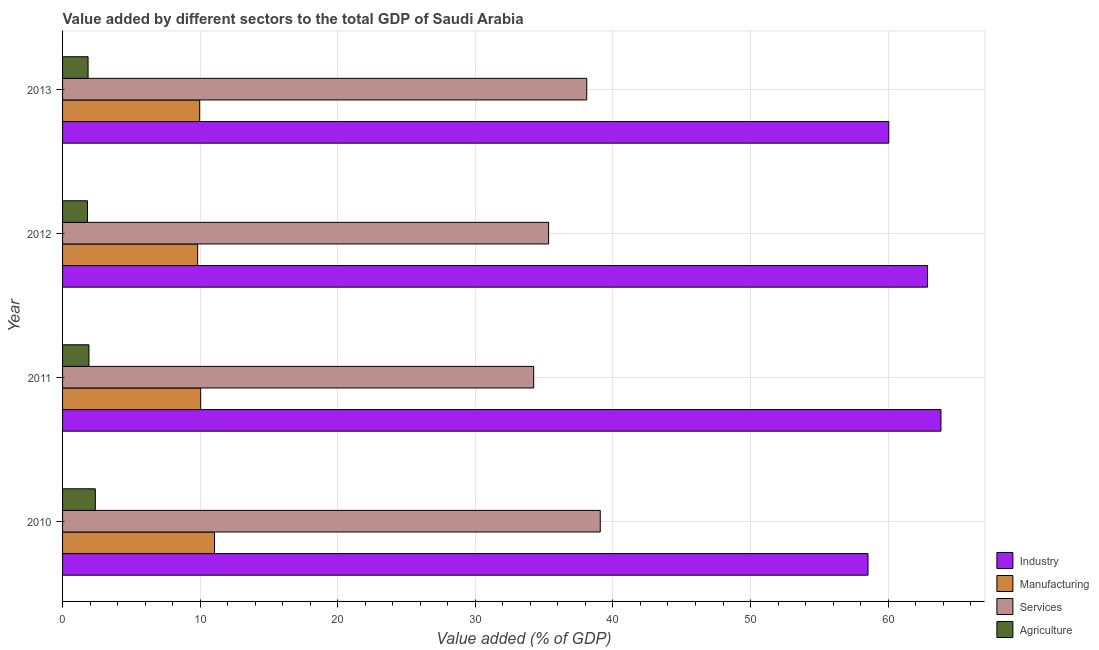How many different coloured bars are there?
Your response must be concise. 4. How many groups of bars are there?
Your response must be concise. 4. How many bars are there on the 3rd tick from the top?
Your response must be concise. 4. How many bars are there on the 2nd tick from the bottom?
Give a very brief answer. 4. What is the label of the 2nd group of bars from the top?
Your answer should be compact. 2012. What is the value added by agricultural sector in 2013?
Your response must be concise. 1.85. Across all years, what is the maximum value added by services sector?
Give a very brief answer. 39.08. Across all years, what is the minimum value added by services sector?
Offer a terse response. 34.24. In which year was the value added by agricultural sector minimum?
Keep it short and to the point. 2012. What is the total value added by industrial sector in the graph?
Offer a terse response. 245.29. What is the difference between the value added by agricultural sector in 2010 and that in 2012?
Make the answer very short. 0.57. What is the difference between the value added by industrial sector in 2013 and the value added by services sector in 2012?
Make the answer very short. 24.72. What is the average value added by manufacturing sector per year?
Your response must be concise. 10.21. In the year 2012, what is the difference between the value added by services sector and value added by industrial sector?
Provide a succinct answer. -27.54. Is the value added by services sector in 2011 less than that in 2013?
Your response must be concise. Yes. What is the difference between the highest and the second highest value added by manufacturing sector?
Make the answer very short. 1.01. In how many years, is the value added by manufacturing sector greater than the average value added by manufacturing sector taken over all years?
Offer a terse response. 1. Is the sum of the value added by manufacturing sector in 2012 and 2013 greater than the maximum value added by industrial sector across all years?
Your answer should be compact. No. What does the 4th bar from the top in 2011 represents?
Make the answer very short. Industry. What does the 2nd bar from the bottom in 2011 represents?
Your answer should be compact. Manufacturing. Are all the bars in the graph horizontal?
Your answer should be compact. Yes. How many years are there in the graph?
Your response must be concise. 4. Does the graph contain grids?
Offer a very short reply. Yes. Where does the legend appear in the graph?
Your response must be concise. Bottom right. What is the title of the graph?
Ensure brevity in your answer.  Value added by different sectors to the total GDP of Saudi Arabia. Does "Mammal species" appear as one of the legend labels in the graph?
Offer a terse response. No. What is the label or title of the X-axis?
Your response must be concise. Value added (% of GDP). What is the label or title of the Y-axis?
Provide a succinct answer. Year. What is the Value added (% of GDP) of Industry in 2010?
Your answer should be very brief. 58.54. What is the Value added (% of GDP) in Manufacturing in 2010?
Provide a short and direct response. 11.04. What is the Value added (% of GDP) in Services in 2010?
Give a very brief answer. 39.08. What is the Value added (% of GDP) of Agriculture in 2010?
Give a very brief answer. 2.38. What is the Value added (% of GDP) of Industry in 2011?
Your response must be concise. 63.84. What is the Value added (% of GDP) in Manufacturing in 2011?
Make the answer very short. 10.04. What is the Value added (% of GDP) of Services in 2011?
Make the answer very short. 34.24. What is the Value added (% of GDP) of Agriculture in 2011?
Make the answer very short. 1.92. What is the Value added (% of GDP) of Industry in 2012?
Keep it short and to the point. 62.86. What is the Value added (% of GDP) in Manufacturing in 2012?
Offer a terse response. 9.82. What is the Value added (% of GDP) of Services in 2012?
Ensure brevity in your answer.  35.33. What is the Value added (% of GDP) in Agriculture in 2012?
Offer a very short reply. 1.81. What is the Value added (% of GDP) of Industry in 2013?
Offer a terse response. 60.05. What is the Value added (% of GDP) in Manufacturing in 2013?
Keep it short and to the point. 9.96. What is the Value added (% of GDP) in Services in 2013?
Ensure brevity in your answer.  38.1. What is the Value added (% of GDP) in Agriculture in 2013?
Give a very brief answer. 1.85. Across all years, what is the maximum Value added (% of GDP) in Industry?
Provide a succinct answer. 63.84. Across all years, what is the maximum Value added (% of GDP) in Manufacturing?
Keep it short and to the point. 11.04. Across all years, what is the maximum Value added (% of GDP) in Services?
Offer a terse response. 39.08. Across all years, what is the maximum Value added (% of GDP) in Agriculture?
Make the answer very short. 2.38. Across all years, what is the minimum Value added (% of GDP) in Industry?
Ensure brevity in your answer.  58.54. Across all years, what is the minimum Value added (% of GDP) of Manufacturing?
Provide a succinct answer. 9.82. Across all years, what is the minimum Value added (% of GDP) in Services?
Your response must be concise. 34.24. Across all years, what is the minimum Value added (% of GDP) of Agriculture?
Keep it short and to the point. 1.81. What is the total Value added (% of GDP) in Industry in the graph?
Offer a very short reply. 245.29. What is the total Value added (% of GDP) of Manufacturing in the graph?
Give a very brief answer. 40.86. What is the total Value added (% of GDP) of Services in the graph?
Provide a short and direct response. 146.74. What is the total Value added (% of GDP) of Agriculture in the graph?
Give a very brief answer. 7.96. What is the difference between the Value added (% of GDP) of Industry in 2010 and that in 2011?
Your answer should be compact. -5.3. What is the difference between the Value added (% of GDP) of Manufacturing in 2010 and that in 2011?
Provide a succinct answer. 1.01. What is the difference between the Value added (% of GDP) of Services in 2010 and that in 2011?
Keep it short and to the point. 4.84. What is the difference between the Value added (% of GDP) in Agriculture in 2010 and that in 2011?
Offer a very short reply. 0.46. What is the difference between the Value added (% of GDP) of Industry in 2010 and that in 2012?
Give a very brief answer. -4.32. What is the difference between the Value added (% of GDP) of Manufacturing in 2010 and that in 2012?
Provide a short and direct response. 1.23. What is the difference between the Value added (% of GDP) in Services in 2010 and that in 2012?
Provide a succinct answer. 3.75. What is the difference between the Value added (% of GDP) in Agriculture in 2010 and that in 2012?
Make the answer very short. 0.57. What is the difference between the Value added (% of GDP) of Industry in 2010 and that in 2013?
Your answer should be very brief. -1.51. What is the difference between the Value added (% of GDP) in Manufacturing in 2010 and that in 2013?
Keep it short and to the point. 1.08. What is the difference between the Value added (% of GDP) in Services in 2010 and that in 2013?
Your answer should be very brief. 0.98. What is the difference between the Value added (% of GDP) in Agriculture in 2010 and that in 2013?
Provide a succinct answer. 0.53. What is the difference between the Value added (% of GDP) of Industry in 2011 and that in 2012?
Ensure brevity in your answer.  0.98. What is the difference between the Value added (% of GDP) of Manufacturing in 2011 and that in 2012?
Your response must be concise. 0.22. What is the difference between the Value added (% of GDP) of Services in 2011 and that in 2012?
Provide a succinct answer. -1.09. What is the difference between the Value added (% of GDP) in Agriculture in 2011 and that in 2012?
Provide a short and direct response. 0.11. What is the difference between the Value added (% of GDP) of Industry in 2011 and that in 2013?
Make the answer very short. 3.79. What is the difference between the Value added (% of GDP) in Manufacturing in 2011 and that in 2013?
Give a very brief answer. 0.08. What is the difference between the Value added (% of GDP) in Services in 2011 and that in 2013?
Your answer should be very brief. -3.86. What is the difference between the Value added (% of GDP) in Agriculture in 2011 and that in 2013?
Ensure brevity in your answer.  0.06. What is the difference between the Value added (% of GDP) in Industry in 2012 and that in 2013?
Ensure brevity in your answer.  2.82. What is the difference between the Value added (% of GDP) of Manufacturing in 2012 and that in 2013?
Your response must be concise. -0.15. What is the difference between the Value added (% of GDP) of Services in 2012 and that in 2013?
Your response must be concise. -2.77. What is the difference between the Value added (% of GDP) in Agriculture in 2012 and that in 2013?
Offer a terse response. -0.04. What is the difference between the Value added (% of GDP) in Industry in 2010 and the Value added (% of GDP) in Manufacturing in 2011?
Offer a very short reply. 48.5. What is the difference between the Value added (% of GDP) in Industry in 2010 and the Value added (% of GDP) in Services in 2011?
Make the answer very short. 24.3. What is the difference between the Value added (% of GDP) in Industry in 2010 and the Value added (% of GDP) in Agriculture in 2011?
Provide a succinct answer. 56.62. What is the difference between the Value added (% of GDP) of Manufacturing in 2010 and the Value added (% of GDP) of Services in 2011?
Offer a very short reply. -23.2. What is the difference between the Value added (% of GDP) in Manufacturing in 2010 and the Value added (% of GDP) in Agriculture in 2011?
Give a very brief answer. 9.13. What is the difference between the Value added (% of GDP) in Services in 2010 and the Value added (% of GDP) in Agriculture in 2011?
Ensure brevity in your answer.  37.16. What is the difference between the Value added (% of GDP) of Industry in 2010 and the Value added (% of GDP) of Manufacturing in 2012?
Provide a succinct answer. 48.72. What is the difference between the Value added (% of GDP) in Industry in 2010 and the Value added (% of GDP) in Services in 2012?
Keep it short and to the point. 23.21. What is the difference between the Value added (% of GDP) in Industry in 2010 and the Value added (% of GDP) in Agriculture in 2012?
Keep it short and to the point. 56.73. What is the difference between the Value added (% of GDP) of Manufacturing in 2010 and the Value added (% of GDP) of Services in 2012?
Your answer should be compact. -24.28. What is the difference between the Value added (% of GDP) in Manufacturing in 2010 and the Value added (% of GDP) in Agriculture in 2012?
Your answer should be very brief. 9.23. What is the difference between the Value added (% of GDP) in Services in 2010 and the Value added (% of GDP) in Agriculture in 2012?
Your response must be concise. 37.27. What is the difference between the Value added (% of GDP) in Industry in 2010 and the Value added (% of GDP) in Manufacturing in 2013?
Your answer should be compact. 48.58. What is the difference between the Value added (% of GDP) in Industry in 2010 and the Value added (% of GDP) in Services in 2013?
Ensure brevity in your answer.  20.44. What is the difference between the Value added (% of GDP) in Industry in 2010 and the Value added (% of GDP) in Agriculture in 2013?
Keep it short and to the point. 56.69. What is the difference between the Value added (% of GDP) in Manufacturing in 2010 and the Value added (% of GDP) in Services in 2013?
Give a very brief answer. -27.05. What is the difference between the Value added (% of GDP) in Manufacturing in 2010 and the Value added (% of GDP) in Agriculture in 2013?
Provide a short and direct response. 9.19. What is the difference between the Value added (% of GDP) in Services in 2010 and the Value added (% of GDP) in Agriculture in 2013?
Ensure brevity in your answer.  37.23. What is the difference between the Value added (% of GDP) of Industry in 2011 and the Value added (% of GDP) of Manufacturing in 2012?
Provide a short and direct response. 54.02. What is the difference between the Value added (% of GDP) in Industry in 2011 and the Value added (% of GDP) in Services in 2012?
Your response must be concise. 28.51. What is the difference between the Value added (% of GDP) in Industry in 2011 and the Value added (% of GDP) in Agriculture in 2012?
Keep it short and to the point. 62.03. What is the difference between the Value added (% of GDP) in Manufacturing in 2011 and the Value added (% of GDP) in Services in 2012?
Ensure brevity in your answer.  -25.29. What is the difference between the Value added (% of GDP) in Manufacturing in 2011 and the Value added (% of GDP) in Agriculture in 2012?
Provide a succinct answer. 8.23. What is the difference between the Value added (% of GDP) in Services in 2011 and the Value added (% of GDP) in Agriculture in 2012?
Offer a terse response. 32.43. What is the difference between the Value added (% of GDP) in Industry in 2011 and the Value added (% of GDP) in Manufacturing in 2013?
Your answer should be very brief. 53.88. What is the difference between the Value added (% of GDP) of Industry in 2011 and the Value added (% of GDP) of Services in 2013?
Provide a short and direct response. 25.74. What is the difference between the Value added (% of GDP) in Industry in 2011 and the Value added (% of GDP) in Agriculture in 2013?
Your answer should be compact. 61.99. What is the difference between the Value added (% of GDP) of Manufacturing in 2011 and the Value added (% of GDP) of Services in 2013?
Offer a terse response. -28.06. What is the difference between the Value added (% of GDP) of Manufacturing in 2011 and the Value added (% of GDP) of Agriculture in 2013?
Your response must be concise. 8.18. What is the difference between the Value added (% of GDP) of Services in 2011 and the Value added (% of GDP) of Agriculture in 2013?
Provide a succinct answer. 32.39. What is the difference between the Value added (% of GDP) in Industry in 2012 and the Value added (% of GDP) in Manufacturing in 2013?
Offer a terse response. 52.9. What is the difference between the Value added (% of GDP) in Industry in 2012 and the Value added (% of GDP) in Services in 2013?
Your answer should be compact. 24.77. What is the difference between the Value added (% of GDP) of Industry in 2012 and the Value added (% of GDP) of Agriculture in 2013?
Your response must be concise. 61.01. What is the difference between the Value added (% of GDP) in Manufacturing in 2012 and the Value added (% of GDP) in Services in 2013?
Your answer should be very brief. -28.28. What is the difference between the Value added (% of GDP) in Manufacturing in 2012 and the Value added (% of GDP) in Agriculture in 2013?
Provide a short and direct response. 7.96. What is the difference between the Value added (% of GDP) of Services in 2012 and the Value added (% of GDP) of Agriculture in 2013?
Your answer should be compact. 33.47. What is the average Value added (% of GDP) of Industry per year?
Provide a short and direct response. 61.32. What is the average Value added (% of GDP) in Manufacturing per year?
Your answer should be compact. 10.21. What is the average Value added (% of GDP) of Services per year?
Your answer should be compact. 36.69. What is the average Value added (% of GDP) in Agriculture per year?
Ensure brevity in your answer.  1.99. In the year 2010, what is the difference between the Value added (% of GDP) of Industry and Value added (% of GDP) of Manufacturing?
Your response must be concise. 47.5. In the year 2010, what is the difference between the Value added (% of GDP) in Industry and Value added (% of GDP) in Services?
Give a very brief answer. 19.46. In the year 2010, what is the difference between the Value added (% of GDP) of Industry and Value added (% of GDP) of Agriculture?
Keep it short and to the point. 56.16. In the year 2010, what is the difference between the Value added (% of GDP) in Manufacturing and Value added (% of GDP) in Services?
Your response must be concise. -28.04. In the year 2010, what is the difference between the Value added (% of GDP) of Manufacturing and Value added (% of GDP) of Agriculture?
Keep it short and to the point. 8.66. In the year 2010, what is the difference between the Value added (% of GDP) in Services and Value added (% of GDP) in Agriculture?
Your answer should be compact. 36.7. In the year 2011, what is the difference between the Value added (% of GDP) in Industry and Value added (% of GDP) in Manufacturing?
Your answer should be compact. 53.8. In the year 2011, what is the difference between the Value added (% of GDP) in Industry and Value added (% of GDP) in Services?
Make the answer very short. 29.6. In the year 2011, what is the difference between the Value added (% of GDP) of Industry and Value added (% of GDP) of Agriculture?
Your response must be concise. 61.92. In the year 2011, what is the difference between the Value added (% of GDP) of Manufacturing and Value added (% of GDP) of Services?
Provide a short and direct response. -24.2. In the year 2011, what is the difference between the Value added (% of GDP) of Manufacturing and Value added (% of GDP) of Agriculture?
Your response must be concise. 8.12. In the year 2011, what is the difference between the Value added (% of GDP) of Services and Value added (% of GDP) of Agriculture?
Provide a succinct answer. 32.32. In the year 2012, what is the difference between the Value added (% of GDP) of Industry and Value added (% of GDP) of Manufacturing?
Make the answer very short. 53.05. In the year 2012, what is the difference between the Value added (% of GDP) in Industry and Value added (% of GDP) in Services?
Provide a succinct answer. 27.54. In the year 2012, what is the difference between the Value added (% of GDP) of Industry and Value added (% of GDP) of Agriculture?
Your response must be concise. 61.05. In the year 2012, what is the difference between the Value added (% of GDP) in Manufacturing and Value added (% of GDP) in Services?
Give a very brief answer. -25.51. In the year 2012, what is the difference between the Value added (% of GDP) in Manufacturing and Value added (% of GDP) in Agriculture?
Keep it short and to the point. 8.01. In the year 2012, what is the difference between the Value added (% of GDP) in Services and Value added (% of GDP) in Agriculture?
Ensure brevity in your answer.  33.52. In the year 2013, what is the difference between the Value added (% of GDP) of Industry and Value added (% of GDP) of Manufacturing?
Offer a very short reply. 50.09. In the year 2013, what is the difference between the Value added (% of GDP) of Industry and Value added (% of GDP) of Services?
Keep it short and to the point. 21.95. In the year 2013, what is the difference between the Value added (% of GDP) in Industry and Value added (% of GDP) in Agriculture?
Offer a very short reply. 58.19. In the year 2013, what is the difference between the Value added (% of GDP) of Manufacturing and Value added (% of GDP) of Services?
Your answer should be compact. -28.14. In the year 2013, what is the difference between the Value added (% of GDP) of Manufacturing and Value added (% of GDP) of Agriculture?
Ensure brevity in your answer.  8.11. In the year 2013, what is the difference between the Value added (% of GDP) in Services and Value added (% of GDP) in Agriculture?
Ensure brevity in your answer.  36.24. What is the ratio of the Value added (% of GDP) in Industry in 2010 to that in 2011?
Ensure brevity in your answer.  0.92. What is the ratio of the Value added (% of GDP) in Manufacturing in 2010 to that in 2011?
Give a very brief answer. 1.1. What is the ratio of the Value added (% of GDP) of Services in 2010 to that in 2011?
Keep it short and to the point. 1.14. What is the ratio of the Value added (% of GDP) of Agriculture in 2010 to that in 2011?
Provide a short and direct response. 1.24. What is the ratio of the Value added (% of GDP) in Industry in 2010 to that in 2012?
Give a very brief answer. 0.93. What is the ratio of the Value added (% of GDP) in Manufacturing in 2010 to that in 2012?
Your response must be concise. 1.12. What is the ratio of the Value added (% of GDP) of Services in 2010 to that in 2012?
Offer a terse response. 1.11. What is the ratio of the Value added (% of GDP) in Agriculture in 2010 to that in 2012?
Keep it short and to the point. 1.32. What is the ratio of the Value added (% of GDP) of Industry in 2010 to that in 2013?
Offer a very short reply. 0.97. What is the ratio of the Value added (% of GDP) in Manufacturing in 2010 to that in 2013?
Your answer should be compact. 1.11. What is the ratio of the Value added (% of GDP) in Services in 2010 to that in 2013?
Your answer should be very brief. 1.03. What is the ratio of the Value added (% of GDP) in Agriculture in 2010 to that in 2013?
Offer a terse response. 1.29. What is the ratio of the Value added (% of GDP) of Industry in 2011 to that in 2012?
Your answer should be compact. 1.02. What is the ratio of the Value added (% of GDP) of Manufacturing in 2011 to that in 2012?
Provide a short and direct response. 1.02. What is the ratio of the Value added (% of GDP) of Services in 2011 to that in 2012?
Offer a terse response. 0.97. What is the ratio of the Value added (% of GDP) in Agriculture in 2011 to that in 2012?
Your answer should be very brief. 1.06. What is the ratio of the Value added (% of GDP) in Industry in 2011 to that in 2013?
Ensure brevity in your answer.  1.06. What is the ratio of the Value added (% of GDP) in Manufacturing in 2011 to that in 2013?
Offer a very short reply. 1.01. What is the ratio of the Value added (% of GDP) of Services in 2011 to that in 2013?
Give a very brief answer. 0.9. What is the ratio of the Value added (% of GDP) in Agriculture in 2011 to that in 2013?
Offer a terse response. 1.03. What is the ratio of the Value added (% of GDP) of Industry in 2012 to that in 2013?
Your answer should be very brief. 1.05. What is the ratio of the Value added (% of GDP) of Manufacturing in 2012 to that in 2013?
Offer a terse response. 0.99. What is the ratio of the Value added (% of GDP) of Services in 2012 to that in 2013?
Give a very brief answer. 0.93. What is the ratio of the Value added (% of GDP) in Agriculture in 2012 to that in 2013?
Offer a very short reply. 0.98. What is the difference between the highest and the second highest Value added (% of GDP) in Industry?
Provide a short and direct response. 0.98. What is the difference between the highest and the second highest Value added (% of GDP) in Services?
Provide a succinct answer. 0.98. What is the difference between the highest and the second highest Value added (% of GDP) of Agriculture?
Provide a short and direct response. 0.46. What is the difference between the highest and the lowest Value added (% of GDP) in Industry?
Provide a succinct answer. 5.3. What is the difference between the highest and the lowest Value added (% of GDP) of Manufacturing?
Make the answer very short. 1.23. What is the difference between the highest and the lowest Value added (% of GDP) in Services?
Your response must be concise. 4.84. What is the difference between the highest and the lowest Value added (% of GDP) of Agriculture?
Keep it short and to the point. 0.57. 